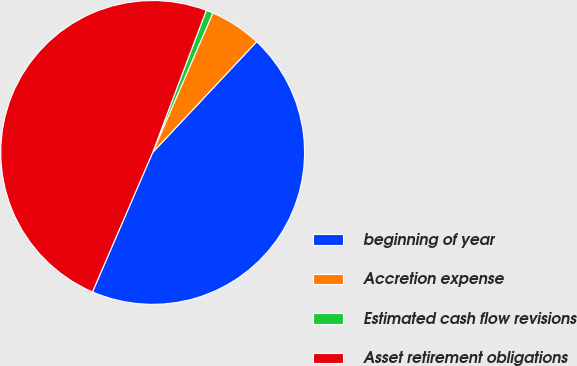Convert chart to OTSL. <chart><loc_0><loc_0><loc_500><loc_500><pie_chart><fcel>beginning of year<fcel>Accretion expense<fcel>Estimated cash flow revisions<fcel>Asset retirement obligations<nl><fcel>44.49%<fcel>5.51%<fcel>0.74%<fcel>49.26%<nl></chart> 